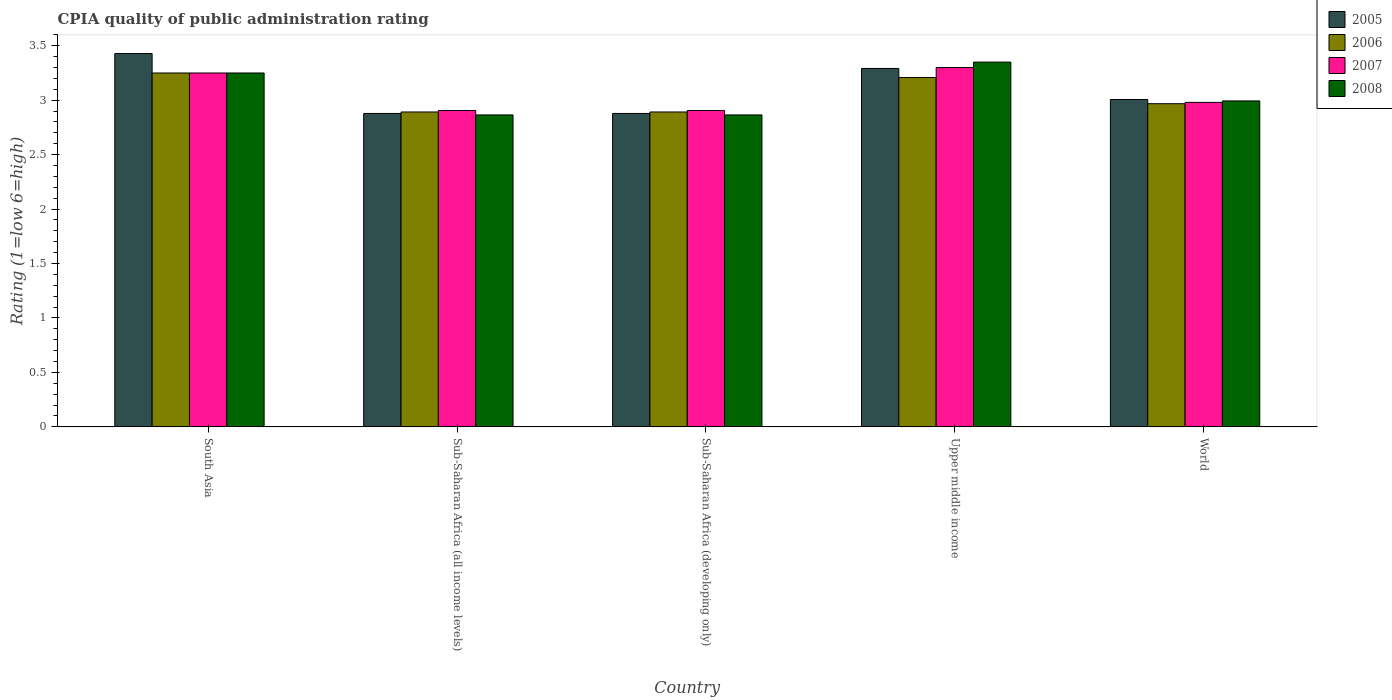How many different coloured bars are there?
Give a very brief answer. 4. How many groups of bars are there?
Offer a very short reply. 5. How many bars are there on the 1st tick from the left?
Your answer should be compact. 4. How many bars are there on the 5th tick from the right?
Your answer should be very brief. 4. What is the CPIA rating in 2008 in Upper middle income?
Give a very brief answer. 3.35. Across all countries, what is the maximum CPIA rating in 2007?
Your answer should be compact. 3.3. Across all countries, what is the minimum CPIA rating in 2007?
Make the answer very short. 2.91. In which country was the CPIA rating in 2006 maximum?
Make the answer very short. South Asia. In which country was the CPIA rating in 2005 minimum?
Provide a succinct answer. Sub-Saharan Africa (all income levels). What is the total CPIA rating in 2005 in the graph?
Your response must be concise. 15.48. What is the difference between the CPIA rating in 2007 in South Asia and that in Upper middle income?
Keep it short and to the point. -0.05. What is the difference between the CPIA rating in 2005 in Upper middle income and the CPIA rating in 2006 in World?
Ensure brevity in your answer.  0.32. What is the average CPIA rating in 2007 per country?
Provide a short and direct response. 3.07. What is the difference between the CPIA rating of/in 2005 and CPIA rating of/in 2007 in Upper middle income?
Provide a short and direct response. -0.01. What is the ratio of the CPIA rating in 2007 in Sub-Saharan Africa (developing only) to that in World?
Make the answer very short. 0.97. Is the CPIA rating in 2006 in South Asia less than that in Upper middle income?
Your response must be concise. No. Is the difference between the CPIA rating in 2005 in Sub-Saharan Africa (all income levels) and World greater than the difference between the CPIA rating in 2007 in Sub-Saharan Africa (all income levels) and World?
Ensure brevity in your answer.  No. What is the difference between the highest and the second highest CPIA rating in 2008?
Give a very brief answer. 0.26. What is the difference between the highest and the lowest CPIA rating in 2007?
Your response must be concise. 0.39. What does the 4th bar from the left in South Asia represents?
Provide a short and direct response. 2008. What does the 1st bar from the right in Sub-Saharan Africa (developing only) represents?
Give a very brief answer. 2008. Is it the case that in every country, the sum of the CPIA rating in 2007 and CPIA rating in 2005 is greater than the CPIA rating in 2008?
Offer a very short reply. Yes. What is the difference between two consecutive major ticks on the Y-axis?
Your answer should be very brief. 0.5. Does the graph contain grids?
Make the answer very short. No. Where does the legend appear in the graph?
Your answer should be very brief. Top right. How are the legend labels stacked?
Offer a very short reply. Vertical. What is the title of the graph?
Your answer should be compact. CPIA quality of public administration rating. What is the label or title of the Y-axis?
Keep it short and to the point. Rating (1=low 6=high). What is the Rating (1=low 6=high) of 2005 in South Asia?
Keep it short and to the point. 3.43. What is the Rating (1=low 6=high) of 2006 in South Asia?
Keep it short and to the point. 3.25. What is the Rating (1=low 6=high) in 2005 in Sub-Saharan Africa (all income levels)?
Your response must be concise. 2.88. What is the Rating (1=low 6=high) in 2006 in Sub-Saharan Africa (all income levels)?
Ensure brevity in your answer.  2.89. What is the Rating (1=low 6=high) of 2007 in Sub-Saharan Africa (all income levels)?
Ensure brevity in your answer.  2.91. What is the Rating (1=low 6=high) of 2008 in Sub-Saharan Africa (all income levels)?
Make the answer very short. 2.86. What is the Rating (1=low 6=high) of 2005 in Sub-Saharan Africa (developing only)?
Your answer should be very brief. 2.88. What is the Rating (1=low 6=high) in 2006 in Sub-Saharan Africa (developing only)?
Your answer should be compact. 2.89. What is the Rating (1=low 6=high) in 2007 in Sub-Saharan Africa (developing only)?
Your response must be concise. 2.91. What is the Rating (1=low 6=high) in 2008 in Sub-Saharan Africa (developing only)?
Offer a very short reply. 2.86. What is the Rating (1=low 6=high) of 2005 in Upper middle income?
Keep it short and to the point. 3.29. What is the Rating (1=low 6=high) in 2006 in Upper middle income?
Keep it short and to the point. 3.21. What is the Rating (1=low 6=high) of 2007 in Upper middle income?
Your answer should be compact. 3.3. What is the Rating (1=low 6=high) in 2008 in Upper middle income?
Make the answer very short. 3.35. What is the Rating (1=low 6=high) in 2005 in World?
Keep it short and to the point. 3.01. What is the Rating (1=low 6=high) in 2006 in World?
Ensure brevity in your answer.  2.97. What is the Rating (1=low 6=high) in 2007 in World?
Your response must be concise. 2.98. What is the Rating (1=low 6=high) in 2008 in World?
Give a very brief answer. 2.99. Across all countries, what is the maximum Rating (1=low 6=high) of 2005?
Your answer should be very brief. 3.43. Across all countries, what is the maximum Rating (1=low 6=high) in 2006?
Provide a succinct answer. 3.25. Across all countries, what is the maximum Rating (1=low 6=high) in 2008?
Offer a very short reply. 3.35. Across all countries, what is the minimum Rating (1=low 6=high) in 2005?
Provide a short and direct response. 2.88. Across all countries, what is the minimum Rating (1=low 6=high) of 2006?
Your answer should be very brief. 2.89. Across all countries, what is the minimum Rating (1=low 6=high) of 2007?
Keep it short and to the point. 2.91. Across all countries, what is the minimum Rating (1=low 6=high) of 2008?
Your answer should be very brief. 2.86. What is the total Rating (1=low 6=high) in 2005 in the graph?
Your response must be concise. 15.48. What is the total Rating (1=low 6=high) in 2006 in the graph?
Offer a very short reply. 15.21. What is the total Rating (1=low 6=high) of 2007 in the graph?
Your response must be concise. 15.34. What is the total Rating (1=low 6=high) in 2008 in the graph?
Your answer should be very brief. 15.32. What is the difference between the Rating (1=low 6=high) in 2005 in South Asia and that in Sub-Saharan Africa (all income levels)?
Offer a terse response. 0.55. What is the difference between the Rating (1=low 6=high) of 2006 in South Asia and that in Sub-Saharan Africa (all income levels)?
Offer a terse response. 0.36. What is the difference between the Rating (1=low 6=high) of 2007 in South Asia and that in Sub-Saharan Africa (all income levels)?
Offer a very short reply. 0.34. What is the difference between the Rating (1=low 6=high) in 2008 in South Asia and that in Sub-Saharan Africa (all income levels)?
Your response must be concise. 0.39. What is the difference between the Rating (1=low 6=high) in 2005 in South Asia and that in Sub-Saharan Africa (developing only)?
Keep it short and to the point. 0.55. What is the difference between the Rating (1=low 6=high) of 2006 in South Asia and that in Sub-Saharan Africa (developing only)?
Provide a succinct answer. 0.36. What is the difference between the Rating (1=low 6=high) in 2007 in South Asia and that in Sub-Saharan Africa (developing only)?
Ensure brevity in your answer.  0.34. What is the difference between the Rating (1=low 6=high) in 2008 in South Asia and that in Sub-Saharan Africa (developing only)?
Make the answer very short. 0.39. What is the difference between the Rating (1=low 6=high) in 2005 in South Asia and that in Upper middle income?
Keep it short and to the point. 0.14. What is the difference between the Rating (1=low 6=high) of 2006 in South Asia and that in Upper middle income?
Offer a very short reply. 0.04. What is the difference between the Rating (1=low 6=high) in 2007 in South Asia and that in Upper middle income?
Offer a terse response. -0.05. What is the difference between the Rating (1=low 6=high) of 2005 in South Asia and that in World?
Provide a succinct answer. 0.42. What is the difference between the Rating (1=low 6=high) of 2006 in South Asia and that in World?
Your answer should be compact. 0.28. What is the difference between the Rating (1=low 6=high) in 2007 in South Asia and that in World?
Offer a very short reply. 0.27. What is the difference between the Rating (1=low 6=high) in 2008 in South Asia and that in World?
Your response must be concise. 0.26. What is the difference between the Rating (1=low 6=high) in 2008 in Sub-Saharan Africa (all income levels) and that in Sub-Saharan Africa (developing only)?
Your answer should be compact. 0. What is the difference between the Rating (1=low 6=high) in 2005 in Sub-Saharan Africa (all income levels) and that in Upper middle income?
Your answer should be compact. -0.41. What is the difference between the Rating (1=low 6=high) in 2006 in Sub-Saharan Africa (all income levels) and that in Upper middle income?
Give a very brief answer. -0.32. What is the difference between the Rating (1=low 6=high) of 2007 in Sub-Saharan Africa (all income levels) and that in Upper middle income?
Provide a short and direct response. -0.39. What is the difference between the Rating (1=low 6=high) in 2008 in Sub-Saharan Africa (all income levels) and that in Upper middle income?
Ensure brevity in your answer.  -0.49. What is the difference between the Rating (1=low 6=high) of 2005 in Sub-Saharan Africa (all income levels) and that in World?
Offer a very short reply. -0.13. What is the difference between the Rating (1=low 6=high) in 2006 in Sub-Saharan Africa (all income levels) and that in World?
Make the answer very short. -0.08. What is the difference between the Rating (1=low 6=high) in 2007 in Sub-Saharan Africa (all income levels) and that in World?
Provide a short and direct response. -0.07. What is the difference between the Rating (1=low 6=high) of 2008 in Sub-Saharan Africa (all income levels) and that in World?
Ensure brevity in your answer.  -0.13. What is the difference between the Rating (1=low 6=high) in 2005 in Sub-Saharan Africa (developing only) and that in Upper middle income?
Provide a short and direct response. -0.41. What is the difference between the Rating (1=low 6=high) of 2006 in Sub-Saharan Africa (developing only) and that in Upper middle income?
Your answer should be compact. -0.32. What is the difference between the Rating (1=low 6=high) in 2007 in Sub-Saharan Africa (developing only) and that in Upper middle income?
Give a very brief answer. -0.39. What is the difference between the Rating (1=low 6=high) of 2008 in Sub-Saharan Africa (developing only) and that in Upper middle income?
Give a very brief answer. -0.49. What is the difference between the Rating (1=low 6=high) of 2005 in Sub-Saharan Africa (developing only) and that in World?
Offer a very short reply. -0.13. What is the difference between the Rating (1=low 6=high) in 2006 in Sub-Saharan Africa (developing only) and that in World?
Ensure brevity in your answer.  -0.08. What is the difference between the Rating (1=low 6=high) in 2007 in Sub-Saharan Africa (developing only) and that in World?
Your response must be concise. -0.07. What is the difference between the Rating (1=low 6=high) in 2008 in Sub-Saharan Africa (developing only) and that in World?
Make the answer very short. -0.13. What is the difference between the Rating (1=low 6=high) in 2005 in Upper middle income and that in World?
Offer a very short reply. 0.29. What is the difference between the Rating (1=low 6=high) in 2006 in Upper middle income and that in World?
Your answer should be compact. 0.24. What is the difference between the Rating (1=low 6=high) in 2007 in Upper middle income and that in World?
Ensure brevity in your answer.  0.32. What is the difference between the Rating (1=low 6=high) in 2008 in Upper middle income and that in World?
Provide a short and direct response. 0.36. What is the difference between the Rating (1=low 6=high) of 2005 in South Asia and the Rating (1=low 6=high) of 2006 in Sub-Saharan Africa (all income levels)?
Offer a very short reply. 0.54. What is the difference between the Rating (1=low 6=high) of 2005 in South Asia and the Rating (1=low 6=high) of 2007 in Sub-Saharan Africa (all income levels)?
Offer a terse response. 0.52. What is the difference between the Rating (1=low 6=high) in 2005 in South Asia and the Rating (1=low 6=high) in 2008 in Sub-Saharan Africa (all income levels)?
Make the answer very short. 0.56. What is the difference between the Rating (1=low 6=high) of 2006 in South Asia and the Rating (1=low 6=high) of 2007 in Sub-Saharan Africa (all income levels)?
Ensure brevity in your answer.  0.34. What is the difference between the Rating (1=low 6=high) in 2006 in South Asia and the Rating (1=low 6=high) in 2008 in Sub-Saharan Africa (all income levels)?
Your answer should be very brief. 0.39. What is the difference between the Rating (1=low 6=high) of 2007 in South Asia and the Rating (1=low 6=high) of 2008 in Sub-Saharan Africa (all income levels)?
Offer a terse response. 0.39. What is the difference between the Rating (1=low 6=high) of 2005 in South Asia and the Rating (1=low 6=high) of 2006 in Sub-Saharan Africa (developing only)?
Your answer should be compact. 0.54. What is the difference between the Rating (1=low 6=high) in 2005 in South Asia and the Rating (1=low 6=high) in 2007 in Sub-Saharan Africa (developing only)?
Offer a very short reply. 0.52. What is the difference between the Rating (1=low 6=high) in 2005 in South Asia and the Rating (1=low 6=high) in 2008 in Sub-Saharan Africa (developing only)?
Offer a terse response. 0.56. What is the difference between the Rating (1=low 6=high) in 2006 in South Asia and the Rating (1=low 6=high) in 2007 in Sub-Saharan Africa (developing only)?
Your answer should be very brief. 0.34. What is the difference between the Rating (1=low 6=high) of 2006 in South Asia and the Rating (1=low 6=high) of 2008 in Sub-Saharan Africa (developing only)?
Provide a short and direct response. 0.39. What is the difference between the Rating (1=low 6=high) in 2007 in South Asia and the Rating (1=low 6=high) in 2008 in Sub-Saharan Africa (developing only)?
Your answer should be very brief. 0.39. What is the difference between the Rating (1=low 6=high) in 2005 in South Asia and the Rating (1=low 6=high) in 2006 in Upper middle income?
Make the answer very short. 0.22. What is the difference between the Rating (1=low 6=high) of 2005 in South Asia and the Rating (1=low 6=high) of 2007 in Upper middle income?
Provide a succinct answer. 0.13. What is the difference between the Rating (1=low 6=high) in 2005 in South Asia and the Rating (1=low 6=high) in 2008 in Upper middle income?
Your response must be concise. 0.08. What is the difference between the Rating (1=low 6=high) in 2007 in South Asia and the Rating (1=low 6=high) in 2008 in Upper middle income?
Your answer should be compact. -0.1. What is the difference between the Rating (1=low 6=high) of 2005 in South Asia and the Rating (1=low 6=high) of 2006 in World?
Your answer should be very brief. 0.46. What is the difference between the Rating (1=low 6=high) in 2005 in South Asia and the Rating (1=low 6=high) in 2007 in World?
Offer a terse response. 0.45. What is the difference between the Rating (1=low 6=high) of 2005 in South Asia and the Rating (1=low 6=high) of 2008 in World?
Provide a short and direct response. 0.44. What is the difference between the Rating (1=low 6=high) of 2006 in South Asia and the Rating (1=low 6=high) of 2007 in World?
Offer a terse response. 0.27. What is the difference between the Rating (1=low 6=high) in 2006 in South Asia and the Rating (1=low 6=high) in 2008 in World?
Offer a very short reply. 0.26. What is the difference between the Rating (1=low 6=high) of 2007 in South Asia and the Rating (1=low 6=high) of 2008 in World?
Your answer should be compact. 0.26. What is the difference between the Rating (1=low 6=high) in 2005 in Sub-Saharan Africa (all income levels) and the Rating (1=low 6=high) in 2006 in Sub-Saharan Africa (developing only)?
Give a very brief answer. -0.01. What is the difference between the Rating (1=low 6=high) in 2005 in Sub-Saharan Africa (all income levels) and the Rating (1=low 6=high) in 2007 in Sub-Saharan Africa (developing only)?
Keep it short and to the point. -0.03. What is the difference between the Rating (1=low 6=high) of 2005 in Sub-Saharan Africa (all income levels) and the Rating (1=low 6=high) of 2008 in Sub-Saharan Africa (developing only)?
Provide a succinct answer. 0.01. What is the difference between the Rating (1=low 6=high) in 2006 in Sub-Saharan Africa (all income levels) and the Rating (1=low 6=high) in 2007 in Sub-Saharan Africa (developing only)?
Keep it short and to the point. -0.01. What is the difference between the Rating (1=low 6=high) in 2006 in Sub-Saharan Africa (all income levels) and the Rating (1=low 6=high) in 2008 in Sub-Saharan Africa (developing only)?
Your answer should be very brief. 0.03. What is the difference between the Rating (1=low 6=high) in 2007 in Sub-Saharan Africa (all income levels) and the Rating (1=low 6=high) in 2008 in Sub-Saharan Africa (developing only)?
Provide a short and direct response. 0.04. What is the difference between the Rating (1=low 6=high) of 2005 in Sub-Saharan Africa (all income levels) and the Rating (1=low 6=high) of 2006 in Upper middle income?
Your response must be concise. -0.33. What is the difference between the Rating (1=low 6=high) of 2005 in Sub-Saharan Africa (all income levels) and the Rating (1=low 6=high) of 2007 in Upper middle income?
Offer a very short reply. -0.42. What is the difference between the Rating (1=low 6=high) in 2005 in Sub-Saharan Africa (all income levels) and the Rating (1=low 6=high) in 2008 in Upper middle income?
Keep it short and to the point. -0.47. What is the difference between the Rating (1=low 6=high) of 2006 in Sub-Saharan Africa (all income levels) and the Rating (1=low 6=high) of 2007 in Upper middle income?
Your answer should be very brief. -0.41. What is the difference between the Rating (1=low 6=high) in 2006 in Sub-Saharan Africa (all income levels) and the Rating (1=low 6=high) in 2008 in Upper middle income?
Give a very brief answer. -0.46. What is the difference between the Rating (1=low 6=high) in 2007 in Sub-Saharan Africa (all income levels) and the Rating (1=low 6=high) in 2008 in Upper middle income?
Offer a very short reply. -0.44. What is the difference between the Rating (1=low 6=high) of 2005 in Sub-Saharan Africa (all income levels) and the Rating (1=low 6=high) of 2006 in World?
Ensure brevity in your answer.  -0.09. What is the difference between the Rating (1=low 6=high) in 2005 in Sub-Saharan Africa (all income levels) and the Rating (1=low 6=high) in 2007 in World?
Your response must be concise. -0.1. What is the difference between the Rating (1=low 6=high) in 2005 in Sub-Saharan Africa (all income levels) and the Rating (1=low 6=high) in 2008 in World?
Offer a very short reply. -0.12. What is the difference between the Rating (1=low 6=high) of 2006 in Sub-Saharan Africa (all income levels) and the Rating (1=low 6=high) of 2007 in World?
Give a very brief answer. -0.09. What is the difference between the Rating (1=low 6=high) in 2006 in Sub-Saharan Africa (all income levels) and the Rating (1=low 6=high) in 2008 in World?
Keep it short and to the point. -0.1. What is the difference between the Rating (1=low 6=high) in 2007 in Sub-Saharan Africa (all income levels) and the Rating (1=low 6=high) in 2008 in World?
Offer a very short reply. -0.09. What is the difference between the Rating (1=low 6=high) in 2005 in Sub-Saharan Africa (developing only) and the Rating (1=low 6=high) in 2006 in Upper middle income?
Ensure brevity in your answer.  -0.33. What is the difference between the Rating (1=low 6=high) of 2005 in Sub-Saharan Africa (developing only) and the Rating (1=low 6=high) of 2007 in Upper middle income?
Give a very brief answer. -0.42. What is the difference between the Rating (1=low 6=high) of 2005 in Sub-Saharan Africa (developing only) and the Rating (1=low 6=high) of 2008 in Upper middle income?
Offer a terse response. -0.47. What is the difference between the Rating (1=low 6=high) of 2006 in Sub-Saharan Africa (developing only) and the Rating (1=low 6=high) of 2007 in Upper middle income?
Provide a short and direct response. -0.41. What is the difference between the Rating (1=low 6=high) in 2006 in Sub-Saharan Africa (developing only) and the Rating (1=low 6=high) in 2008 in Upper middle income?
Ensure brevity in your answer.  -0.46. What is the difference between the Rating (1=low 6=high) in 2007 in Sub-Saharan Africa (developing only) and the Rating (1=low 6=high) in 2008 in Upper middle income?
Your response must be concise. -0.44. What is the difference between the Rating (1=low 6=high) in 2005 in Sub-Saharan Africa (developing only) and the Rating (1=low 6=high) in 2006 in World?
Ensure brevity in your answer.  -0.09. What is the difference between the Rating (1=low 6=high) in 2005 in Sub-Saharan Africa (developing only) and the Rating (1=low 6=high) in 2007 in World?
Offer a very short reply. -0.1. What is the difference between the Rating (1=low 6=high) in 2005 in Sub-Saharan Africa (developing only) and the Rating (1=low 6=high) in 2008 in World?
Ensure brevity in your answer.  -0.12. What is the difference between the Rating (1=low 6=high) of 2006 in Sub-Saharan Africa (developing only) and the Rating (1=low 6=high) of 2007 in World?
Offer a very short reply. -0.09. What is the difference between the Rating (1=low 6=high) of 2006 in Sub-Saharan Africa (developing only) and the Rating (1=low 6=high) of 2008 in World?
Your answer should be compact. -0.1. What is the difference between the Rating (1=low 6=high) in 2007 in Sub-Saharan Africa (developing only) and the Rating (1=low 6=high) in 2008 in World?
Make the answer very short. -0.09. What is the difference between the Rating (1=low 6=high) in 2005 in Upper middle income and the Rating (1=low 6=high) in 2006 in World?
Offer a terse response. 0.32. What is the difference between the Rating (1=low 6=high) in 2005 in Upper middle income and the Rating (1=low 6=high) in 2007 in World?
Provide a short and direct response. 0.31. What is the difference between the Rating (1=low 6=high) of 2005 in Upper middle income and the Rating (1=low 6=high) of 2008 in World?
Keep it short and to the point. 0.3. What is the difference between the Rating (1=low 6=high) in 2006 in Upper middle income and the Rating (1=low 6=high) in 2007 in World?
Give a very brief answer. 0.23. What is the difference between the Rating (1=low 6=high) of 2006 in Upper middle income and the Rating (1=low 6=high) of 2008 in World?
Make the answer very short. 0.21. What is the difference between the Rating (1=low 6=high) of 2007 in Upper middle income and the Rating (1=low 6=high) of 2008 in World?
Your answer should be very brief. 0.31. What is the average Rating (1=low 6=high) of 2005 per country?
Give a very brief answer. 3.1. What is the average Rating (1=low 6=high) in 2006 per country?
Your response must be concise. 3.04. What is the average Rating (1=low 6=high) of 2007 per country?
Ensure brevity in your answer.  3.07. What is the average Rating (1=low 6=high) of 2008 per country?
Ensure brevity in your answer.  3.06. What is the difference between the Rating (1=low 6=high) in 2005 and Rating (1=low 6=high) in 2006 in South Asia?
Your response must be concise. 0.18. What is the difference between the Rating (1=low 6=high) of 2005 and Rating (1=low 6=high) of 2007 in South Asia?
Give a very brief answer. 0.18. What is the difference between the Rating (1=low 6=high) in 2005 and Rating (1=low 6=high) in 2008 in South Asia?
Give a very brief answer. 0.18. What is the difference between the Rating (1=low 6=high) in 2005 and Rating (1=low 6=high) in 2006 in Sub-Saharan Africa (all income levels)?
Give a very brief answer. -0.01. What is the difference between the Rating (1=low 6=high) in 2005 and Rating (1=low 6=high) in 2007 in Sub-Saharan Africa (all income levels)?
Make the answer very short. -0.03. What is the difference between the Rating (1=low 6=high) of 2005 and Rating (1=low 6=high) of 2008 in Sub-Saharan Africa (all income levels)?
Offer a terse response. 0.01. What is the difference between the Rating (1=low 6=high) in 2006 and Rating (1=low 6=high) in 2007 in Sub-Saharan Africa (all income levels)?
Keep it short and to the point. -0.01. What is the difference between the Rating (1=low 6=high) in 2006 and Rating (1=low 6=high) in 2008 in Sub-Saharan Africa (all income levels)?
Your answer should be very brief. 0.03. What is the difference between the Rating (1=low 6=high) in 2007 and Rating (1=low 6=high) in 2008 in Sub-Saharan Africa (all income levels)?
Make the answer very short. 0.04. What is the difference between the Rating (1=low 6=high) in 2005 and Rating (1=low 6=high) in 2006 in Sub-Saharan Africa (developing only)?
Give a very brief answer. -0.01. What is the difference between the Rating (1=low 6=high) of 2005 and Rating (1=low 6=high) of 2007 in Sub-Saharan Africa (developing only)?
Keep it short and to the point. -0.03. What is the difference between the Rating (1=low 6=high) in 2005 and Rating (1=low 6=high) in 2008 in Sub-Saharan Africa (developing only)?
Offer a very short reply. 0.01. What is the difference between the Rating (1=low 6=high) of 2006 and Rating (1=low 6=high) of 2007 in Sub-Saharan Africa (developing only)?
Offer a very short reply. -0.01. What is the difference between the Rating (1=low 6=high) of 2006 and Rating (1=low 6=high) of 2008 in Sub-Saharan Africa (developing only)?
Provide a short and direct response. 0.03. What is the difference between the Rating (1=low 6=high) in 2007 and Rating (1=low 6=high) in 2008 in Sub-Saharan Africa (developing only)?
Your answer should be compact. 0.04. What is the difference between the Rating (1=low 6=high) in 2005 and Rating (1=low 6=high) in 2006 in Upper middle income?
Your answer should be very brief. 0.08. What is the difference between the Rating (1=low 6=high) in 2005 and Rating (1=low 6=high) in 2007 in Upper middle income?
Provide a succinct answer. -0.01. What is the difference between the Rating (1=low 6=high) in 2005 and Rating (1=low 6=high) in 2008 in Upper middle income?
Give a very brief answer. -0.06. What is the difference between the Rating (1=low 6=high) in 2006 and Rating (1=low 6=high) in 2007 in Upper middle income?
Offer a terse response. -0.09. What is the difference between the Rating (1=low 6=high) in 2006 and Rating (1=low 6=high) in 2008 in Upper middle income?
Provide a succinct answer. -0.14. What is the difference between the Rating (1=low 6=high) in 2007 and Rating (1=low 6=high) in 2008 in Upper middle income?
Give a very brief answer. -0.05. What is the difference between the Rating (1=low 6=high) in 2005 and Rating (1=low 6=high) in 2006 in World?
Offer a very short reply. 0.04. What is the difference between the Rating (1=low 6=high) of 2005 and Rating (1=low 6=high) of 2007 in World?
Your answer should be compact. 0.03. What is the difference between the Rating (1=low 6=high) in 2005 and Rating (1=low 6=high) in 2008 in World?
Ensure brevity in your answer.  0.01. What is the difference between the Rating (1=low 6=high) in 2006 and Rating (1=low 6=high) in 2007 in World?
Keep it short and to the point. -0.01. What is the difference between the Rating (1=low 6=high) of 2006 and Rating (1=low 6=high) of 2008 in World?
Provide a succinct answer. -0.03. What is the difference between the Rating (1=low 6=high) in 2007 and Rating (1=low 6=high) in 2008 in World?
Provide a succinct answer. -0.01. What is the ratio of the Rating (1=low 6=high) in 2005 in South Asia to that in Sub-Saharan Africa (all income levels)?
Your answer should be very brief. 1.19. What is the ratio of the Rating (1=low 6=high) of 2006 in South Asia to that in Sub-Saharan Africa (all income levels)?
Offer a terse response. 1.12. What is the ratio of the Rating (1=low 6=high) in 2007 in South Asia to that in Sub-Saharan Africa (all income levels)?
Your answer should be very brief. 1.12. What is the ratio of the Rating (1=low 6=high) in 2008 in South Asia to that in Sub-Saharan Africa (all income levels)?
Your answer should be very brief. 1.13. What is the ratio of the Rating (1=low 6=high) in 2005 in South Asia to that in Sub-Saharan Africa (developing only)?
Your response must be concise. 1.19. What is the ratio of the Rating (1=low 6=high) of 2006 in South Asia to that in Sub-Saharan Africa (developing only)?
Your answer should be very brief. 1.12. What is the ratio of the Rating (1=low 6=high) in 2007 in South Asia to that in Sub-Saharan Africa (developing only)?
Provide a succinct answer. 1.12. What is the ratio of the Rating (1=low 6=high) in 2008 in South Asia to that in Sub-Saharan Africa (developing only)?
Provide a short and direct response. 1.13. What is the ratio of the Rating (1=low 6=high) in 2005 in South Asia to that in Upper middle income?
Your answer should be very brief. 1.04. What is the ratio of the Rating (1=low 6=high) of 2006 in South Asia to that in Upper middle income?
Your answer should be very brief. 1.01. What is the ratio of the Rating (1=low 6=high) of 2008 in South Asia to that in Upper middle income?
Ensure brevity in your answer.  0.97. What is the ratio of the Rating (1=low 6=high) in 2005 in South Asia to that in World?
Provide a succinct answer. 1.14. What is the ratio of the Rating (1=low 6=high) in 2006 in South Asia to that in World?
Give a very brief answer. 1.09. What is the ratio of the Rating (1=low 6=high) of 2007 in South Asia to that in World?
Make the answer very short. 1.09. What is the ratio of the Rating (1=low 6=high) of 2008 in South Asia to that in World?
Offer a very short reply. 1.09. What is the ratio of the Rating (1=low 6=high) in 2005 in Sub-Saharan Africa (all income levels) to that in Sub-Saharan Africa (developing only)?
Your answer should be very brief. 1. What is the ratio of the Rating (1=low 6=high) of 2006 in Sub-Saharan Africa (all income levels) to that in Sub-Saharan Africa (developing only)?
Your response must be concise. 1. What is the ratio of the Rating (1=low 6=high) in 2007 in Sub-Saharan Africa (all income levels) to that in Sub-Saharan Africa (developing only)?
Make the answer very short. 1. What is the ratio of the Rating (1=low 6=high) of 2008 in Sub-Saharan Africa (all income levels) to that in Sub-Saharan Africa (developing only)?
Your answer should be very brief. 1. What is the ratio of the Rating (1=low 6=high) in 2005 in Sub-Saharan Africa (all income levels) to that in Upper middle income?
Provide a short and direct response. 0.87. What is the ratio of the Rating (1=low 6=high) in 2006 in Sub-Saharan Africa (all income levels) to that in Upper middle income?
Offer a terse response. 0.9. What is the ratio of the Rating (1=low 6=high) of 2007 in Sub-Saharan Africa (all income levels) to that in Upper middle income?
Offer a very short reply. 0.88. What is the ratio of the Rating (1=low 6=high) in 2008 in Sub-Saharan Africa (all income levels) to that in Upper middle income?
Provide a short and direct response. 0.86. What is the ratio of the Rating (1=low 6=high) of 2005 in Sub-Saharan Africa (all income levels) to that in World?
Ensure brevity in your answer.  0.96. What is the ratio of the Rating (1=low 6=high) of 2006 in Sub-Saharan Africa (all income levels) to that in World?
Offer a very short reply. 0.97. What is the ratio of the Rating (1=low 6=high) of 2008 in Sub-Saharan Africa (all income levels) to that in World?
Your answer should be compact. 0.96. What is the ratio of the Rating (1=low 6=high) in 2005 in Sub-Saharan Africa (developing only) to that in Upper middle income?
Your answer should be very brief. 0.87. What is the ratio of the Rating (1=low 6=high) in 2006 in Sub-Saharan Africa (developing only) to that in Upper middle income?
Provide a succinct answer. 0.9. What is the ratio of the Rating (1=low 6=high) in 2007 in Sub-Saharan Africa (developing only) to that in Upper middle income?
Your answer should be compact. 0.88. What is the ratio of the Rating (1=low 6=high) in 2008 in Sub-Saharan Africa (developing only) to that in Upper middle income?
Your answer should be very brief. 0.86. What is the ratio of the Rating (1=low 6=high) of 2005 in Sub-Saharan Africa (developing only) to that in World?
Your answer should be very brief. 0.96. What is the ratio of the Rating (1=low 6=high) of 2006 in Sub-Saharan Africa (developing only) to that in World?
Offer a very short reply. 0.97. What is the ratio of the Rating (1=low 6=high) in 2008 in Sub-Saharan Africa (developing only) to that in World?
Offer a terse response. 0.96. What is the ratio of the Rating (1=low 6=high) in 2005 in Upper middle income to that in World?
Provide a succinct answer. 1.09. What is the ratio of the Rating (1=low 6=high) of 2006 in Upper middle income to that in World?
Your answer should be very brief. 1.08. What is the ratio of the Rating (1=low 6=high) of 2007 in Upper middle income to that in World?
Keep it short and to the point. 1.11. What is the ratio of the Rating (1=low 6=high) of 2008 in Upper middle income to that in World?
Provide a short and direct response. 1.12. What is the difference between the highest and the second highest Rating (1=low 6=high) in 2005?
Provide a succinct answer. 0.14. What is the difference between the highest and the second highest Rating (1=low 6=high) in 2006?
Provide a succinct answer. 0.04. What is the difference between the highest and the second highest Rating (1=low 6=high) of 2007?
Give a very brief answer. 0.05. What is the difference between the highest and the lowest Rating (1=low 6=high) of 2005?
Make the answer very short. 0.55. What is the difference between the highest and the lowest Rating (1=low 6=high) in 2006?
Offer a terse response. 0.36. What is the difference between the highest and the lowest Rating (1=low 6=high) of 2007?
Make the answer very short. 0.39. What is the difference between the highest and the lowest Rating (1=low 6=high) in 2008?
Keep it short and to the point. 0.49. 